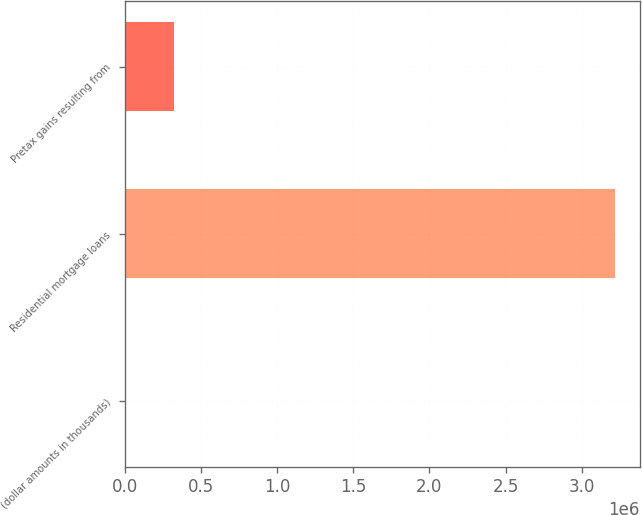Convert chart. <chart><loc_0><loc_0><loc_500><loc_500><bar_chart><fcel>(dollar amounts in thousands)<fcel>Residential mortgage loans<fcel>Pretax gains resulting from<nl><fcel>2013<fcel>3.22124e+06<fcel>323936<nl></chart> 